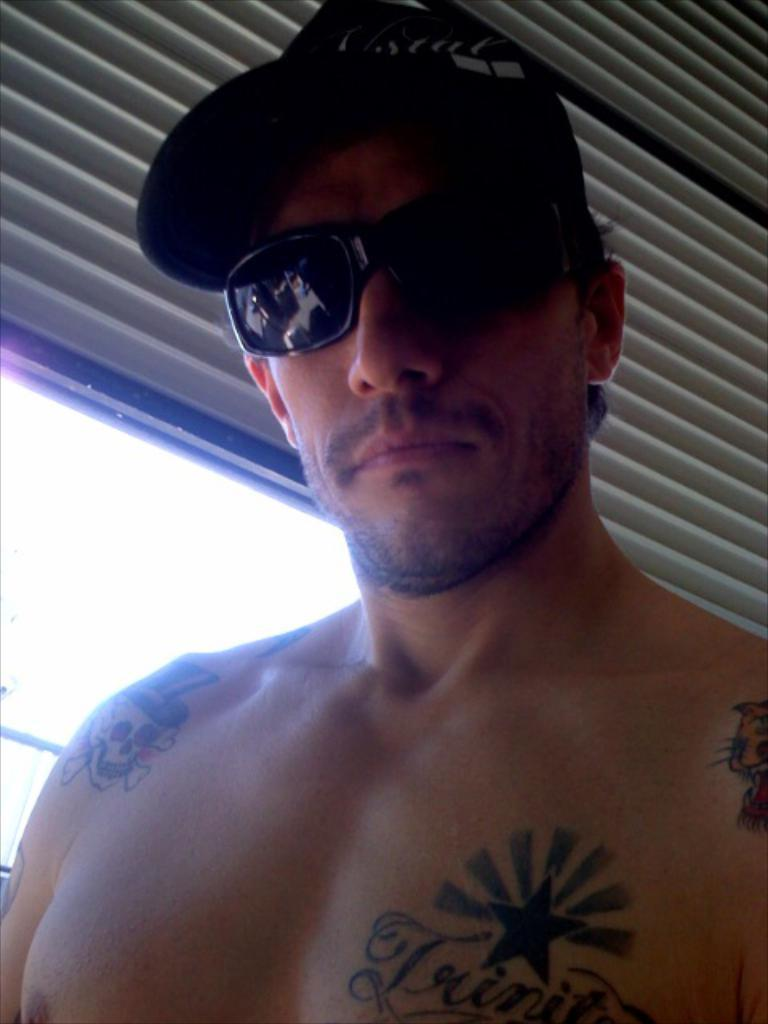What type of protective eyewear is the person wearing in the image? The person is wearing goggles in the image. What type of headwear is the person wearing in the image? The person is wearing a cap in the image. Are there any visible markings or designs on the person's body? Yes, there are tattoos on the person's body. What can be seen through the window in the image? The facts provided do not specify what can be seen through the window. What type of veil is the stranger wearing in the image? There is no stranger or veil present in the image. Is there any smoke visible in the image? There is no smoke present in the image. 